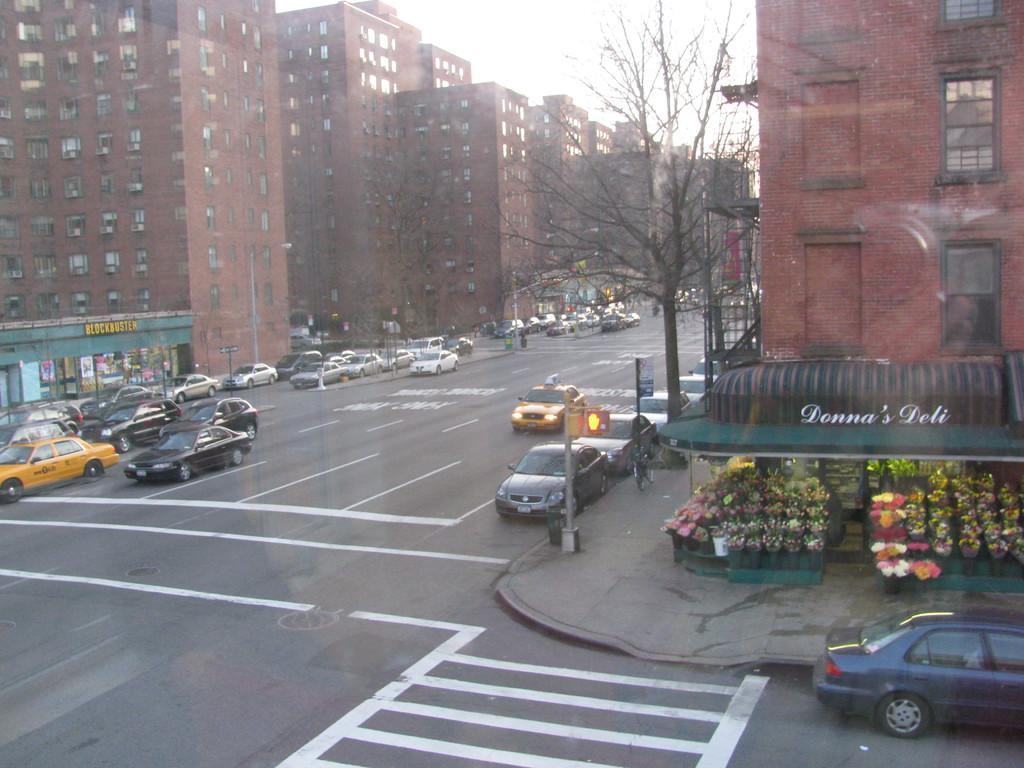How would you summarize this image in a sentence or two? This picture is clicked outside the city. At the bottom of the picture, we see the road. Here, we see cars are moving on the road. On the right side, we see a building and a flower bouquet shop. Beside that, there are trees and a pole. In the background, there are buildings. At the top of the picture, we see the sky. 